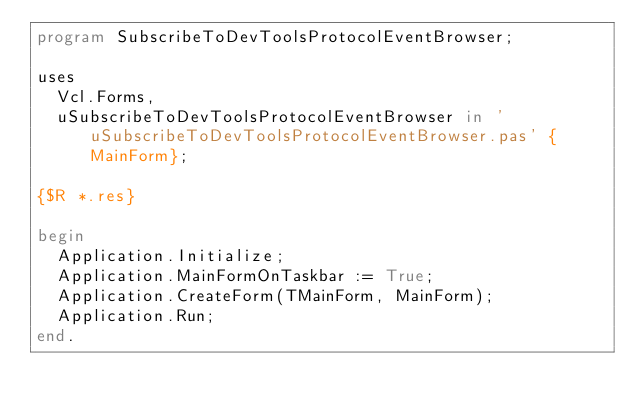Convert code to text. <code><loc_0><loc_0><loc_500><loc_500><_Pascal_>program SubscribeToDevToolsProtocolEventBrowser;

uses
  Vcl.Forms,
  uSubscribeToDevToolsProtocolEventBrowser in 'uSubscribeToDevToolsProtocolEventBrowser.pas' {MainForm};

{$R *.res}

begin
  Application.Initialize;
  Application.MainFormOnTaskbar := True;
  Application.CreateForm(TMainForm, MainForm);
  Application.Run;
end.
</code> 